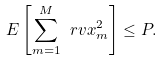Convert formula to latex. <formula><loc_0><loc_0><loc_500><loc_500>E \left [ \sum _ { m = 1 } ^ { M } \ r v x _ { m } ^ { 2 } \right ] \leq P .</formula> 